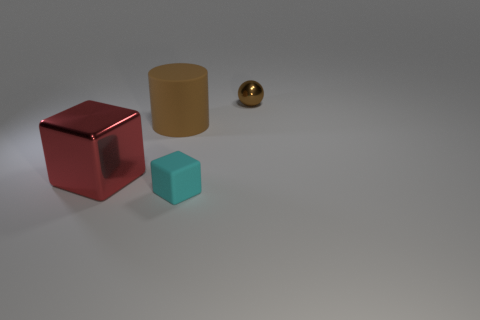The object that is the same color as the small metal sphere is what size?
Your response must be concise. Large. What shape is the object that is the same color as the tiny metal sphere?
Your answer should be compact. Cylinder. Are there any other things of the same color as the large matte object?
Provide a short and direct response. Yes. Do the brown thing that is in front of the small brown metallic ball and the cube that is right of the large red metallic cube have the same size?
Your answer should be compact. No. Are there an equal number of small cyan rubber cubes that are right of the cyan thing and red metal cubes that are in front of the tiny brown object?
Ensure brevity in your answer.  No. There is a red metallic object; does it have the same size as the cyan cube to the right of the red metal thing?
Provide a succinct answer. No. There is a brown object in front of the tiny brown metallic ball; are there any metal blocks to the left of it?
Your response must be concise. Yes. Is there a small purple matte object of the same shape as the big brown matte thing?
Make the answer very short. No. What number of red cubes are behind the brown thing behind the large object behind the big shiny object?
Offer a terse response. 0. Does the small cube have the same color as the cube that is to the left of the matte block?
Keep it short and to the point. No. 